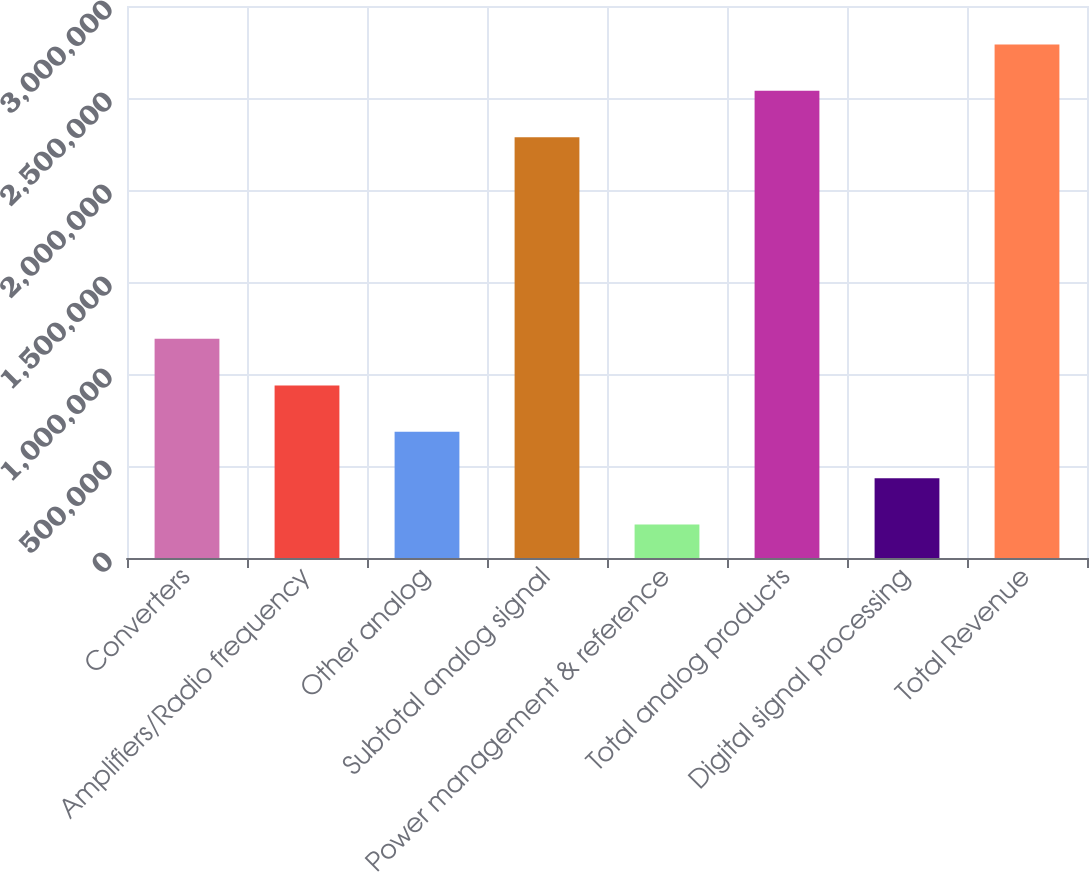Convert chart. <chart><loc_0><loc_0><loc_500><loc_500><bar_chart><fcel>Converters<fcel>Amplifiers/Radio frequency<fcel>Other analog<fcel>Subtotal analog signal<fcel>Power management & reference<fcel>Total analog products<fcel>Digital signal processing<fcel>Total Revenue<nl><fcel>1.19206e+06<fcel>937836<fcel>685936<fcel>2.28713e+06<fcel>182134<fcel>2.53903e+06<fcel>434035<fcel>2.79093e+06<nl></chart> 